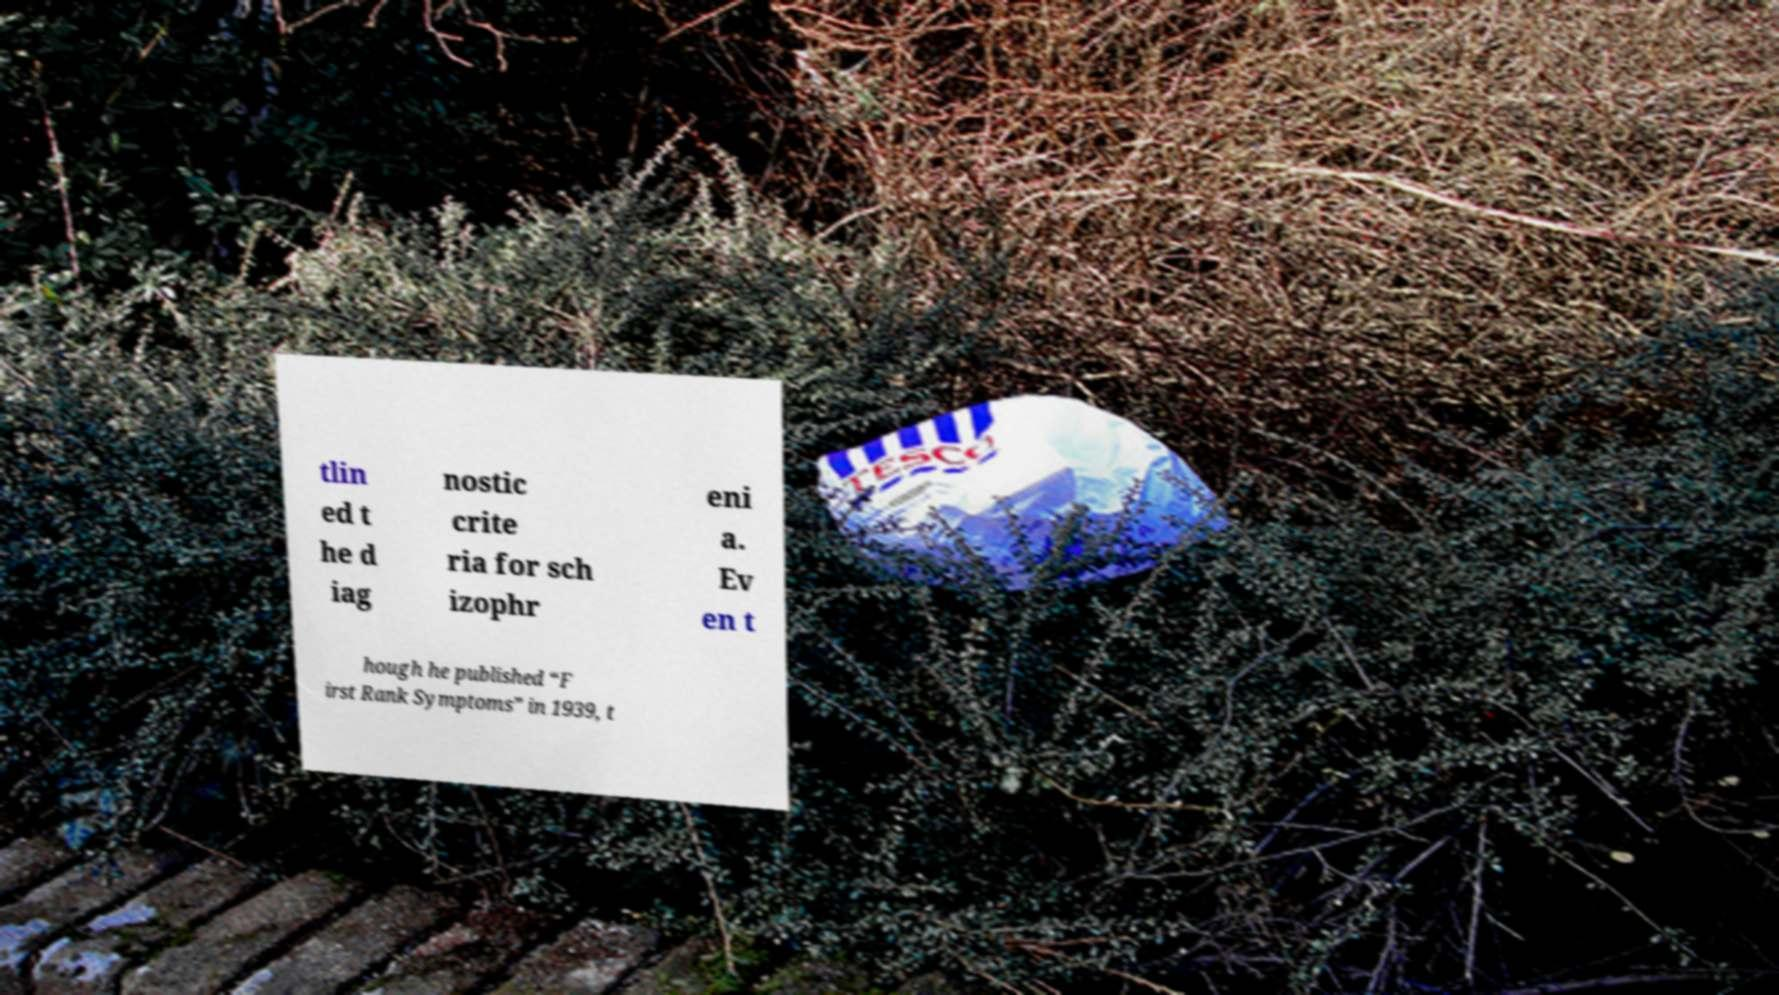There's text embedded in this image that I need extracted. Can you transcribe it verbatim? tlin ed t he d iag nostic crite ria for sch izophr eni a. Ev en t hough he published “F irst Rank Symptoms” in 1939, t 